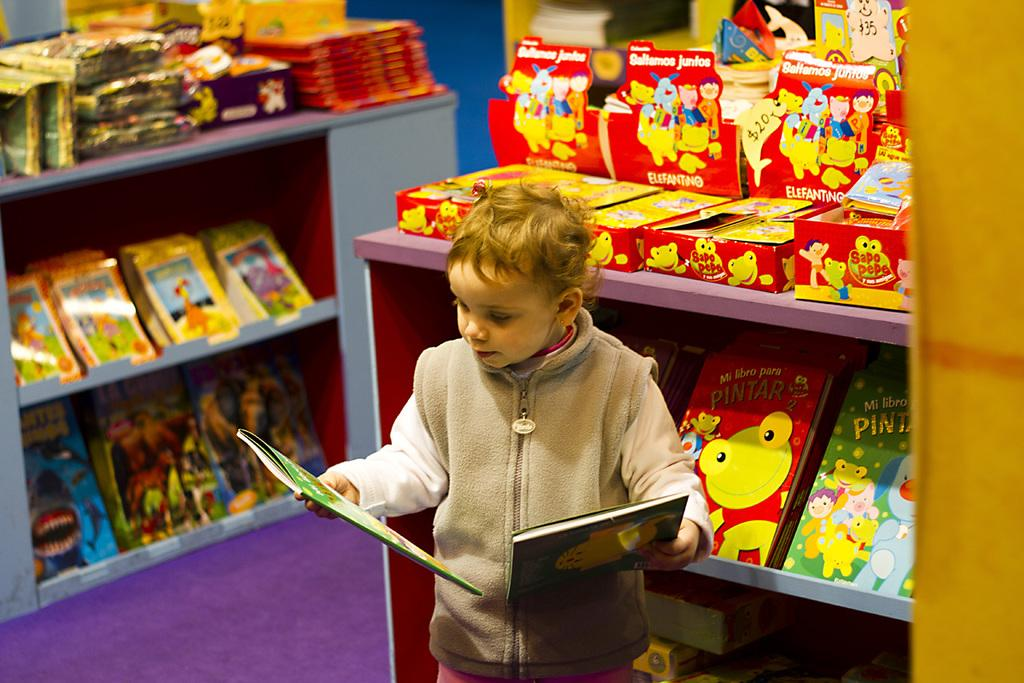Provide a one-sentence caption for the provided image. The book entitled "Mi Libro Para Pintar" is on the shelf behind the small boy looking at another book. 